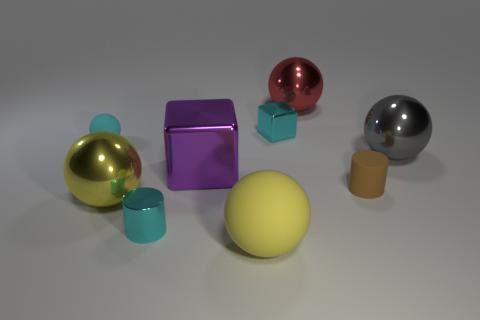Add 1 red metallic balls. How many objects exist? 10 Subtract all red spheres. How many spheres are left? 4 Subtract all red balls. How many balls are left? 4 Subtract 2 balls. How many balls are left? 3 Subtract all green cubes. How many cyan cylinders are left? 1 Subtract all gray metallic things. Subtract all big metallic things. How many objects are left? 4 Add 9 big yellow matte balls. How many big yellow matte balls are left? 10 Add 1 small yellow matte spheres. How many small yellow matte spheres exist? 1 Subtract 0 yellow cubes. How many objects are left? 9 Subtract all cylinders. How many objects are left? 7 